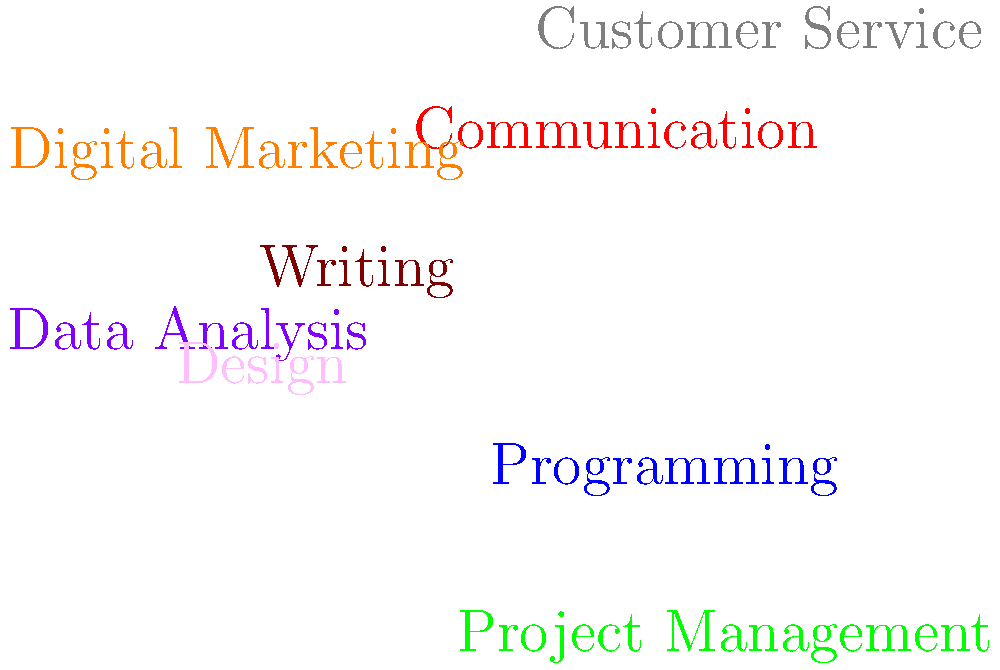Based on the word cloud visualization of remote work skills, which skill appears to be the most in-demand? To determine the most in-demand remote work skill from the word cloud visualization, we need to follow these steps:

1. Analyze the visual representation: In a word cloud, the size of each word typically corresponds to its importance or frequency.

2. Identify the largest word: The word with the largest font size is usually the most significant or in-demand skill.

3. Compare sizes: In this word cloud, we can see that "Programming" appears to be the largest word.

4. Consider color: While color can sometimes indicate importance, in this case, it's primarily used for visual distinction and doesn't affect our analysis.

5. Compare with other prominent words: Other notable skills like "Communication" and "Project Management" are also displayed in relatively large text, but not as large as "Programming".

6. Context consideration: Given that this is a word cloud for remote work skills, it makes sense that programming would be highly in-demand, as many remote jobs are in the tech industry.

Based on this analysis, we can conclude that Programming is represented as the most in-demand skill in this word cloud visualization.
Answer: Programming 